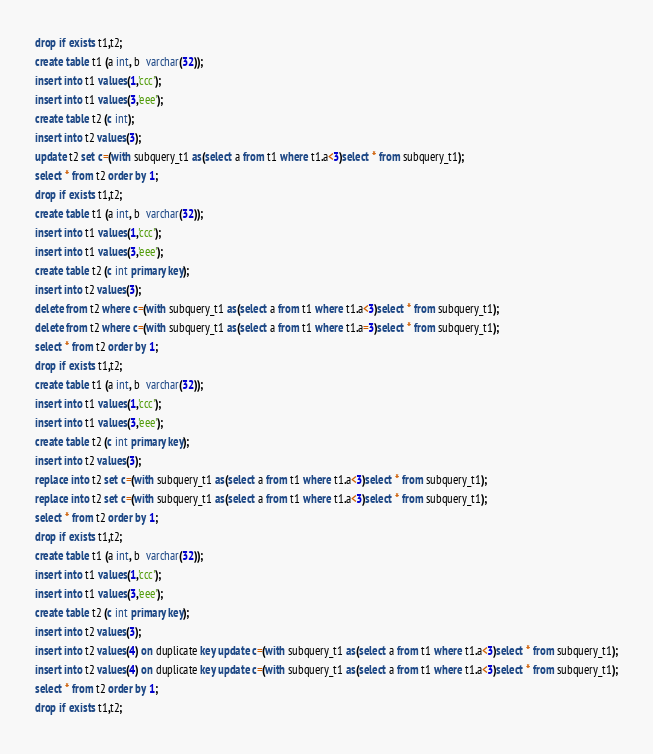<code> <loc_0><loc_0><loc_500><loc_500><_SQL_>drop if exists t1,t2;
create table t1 (a int, b  varchar(32));
insert into t1 values(1,'ccc');
insert into t1 values(3,'eee');
create table t2 (c int);
insert into t2 values(3);
update t2 set c=(with subquery_t1 as(select a from t1 where t1.a<3)select * from subquery_t1);
select * from t2 order by 1;
drop if exists t1,t2;   
create table t1 (a int, b  varchar(32));
insert into t1 values(1,'ccc');
insert into t1 values(3,'eee');
create table t2 (c int primary key);
insert into t2 values(3);
delete from t2 where c=(with subquery_t1 as(select a from t1 where t1.a<3)select * from subquery_t1);
delete from t2 where c=(with subquery_t1 as(select a from t1 where t1.a=3)select * from subquery_t1);
select * from t2 order by 1;
drop if exists t1,t2;
create table t1 (a int, b  varchar(32));
insert into t1 values(1,'ccc');
insert into t1 values(3,'eee');
create table t2 (c int primary key);
insert into t2 values(3);
replace into t2 set c=(with subquery_t1 as(select a from t1 where t1.a<3)select * from subquery_t1);
replace into t2 set c=(with subquery_t1 as(select a from t1 where t1.a<3)select * from subquery_t1);
select * from t2 order by 1;
drop if exists t1,t2;
create table t1 (a int, b  varchar(32));
insert into t1 values(1,'ccc');
insert into t1 values(3,'eee');
create table t2 (c int primary key);
insert into t2 values(3);
insert into t2 values(4) on duplicate key update c=(with subquery_t1 as(select a from t1 where t1.a<3)select * from subquery_t1);
insert into t2 values(4) on duplicate key update c=(with subquery_t1 as(select a from t1 where t1.a<3)select * from subquery_t1);
select * from t2 order by 1;
drop if exists t1,t2;
</code> 